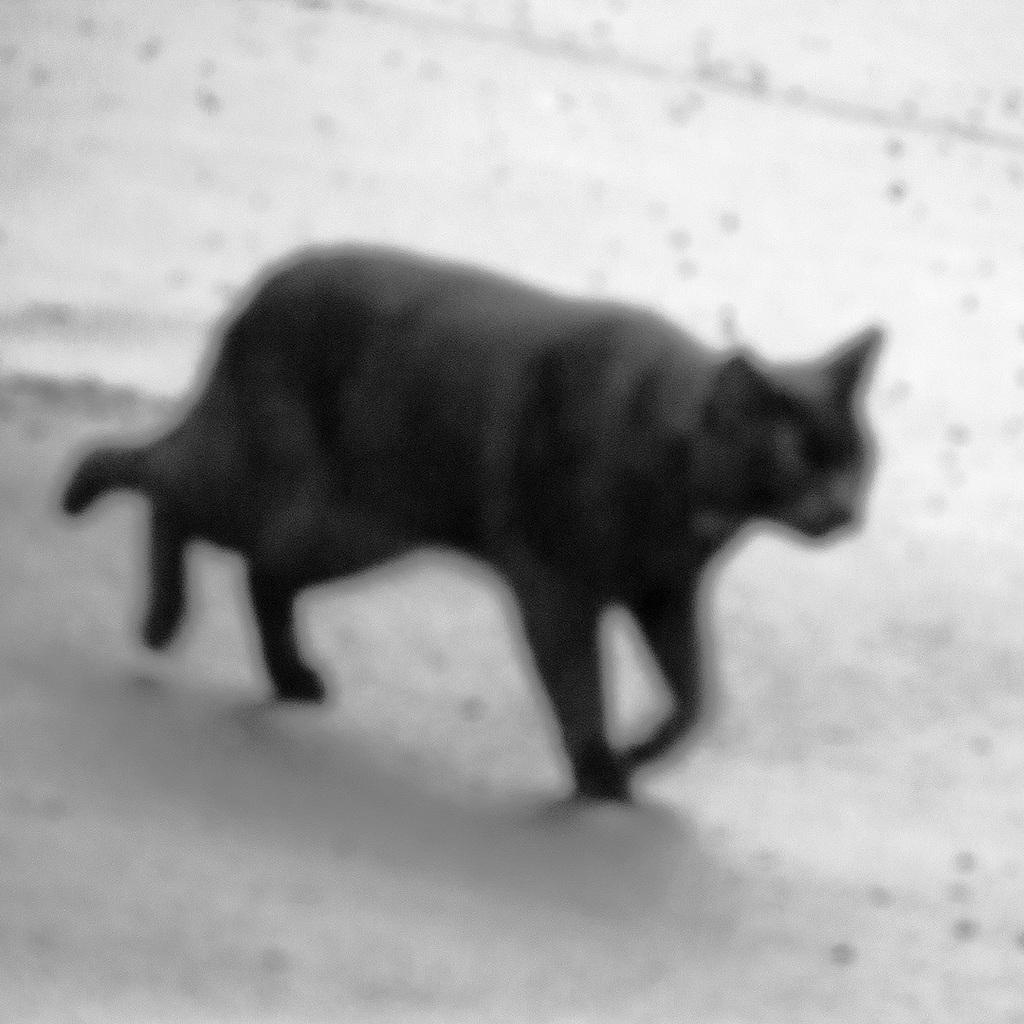Describe this image in one or two sentences. In this picture, there is a black cat moving towards the right. The image is little blurred. 